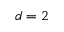Convert formula to latex. <formula><loc_0><loc_0><loc_500><loc_500>d = 2</formula> 